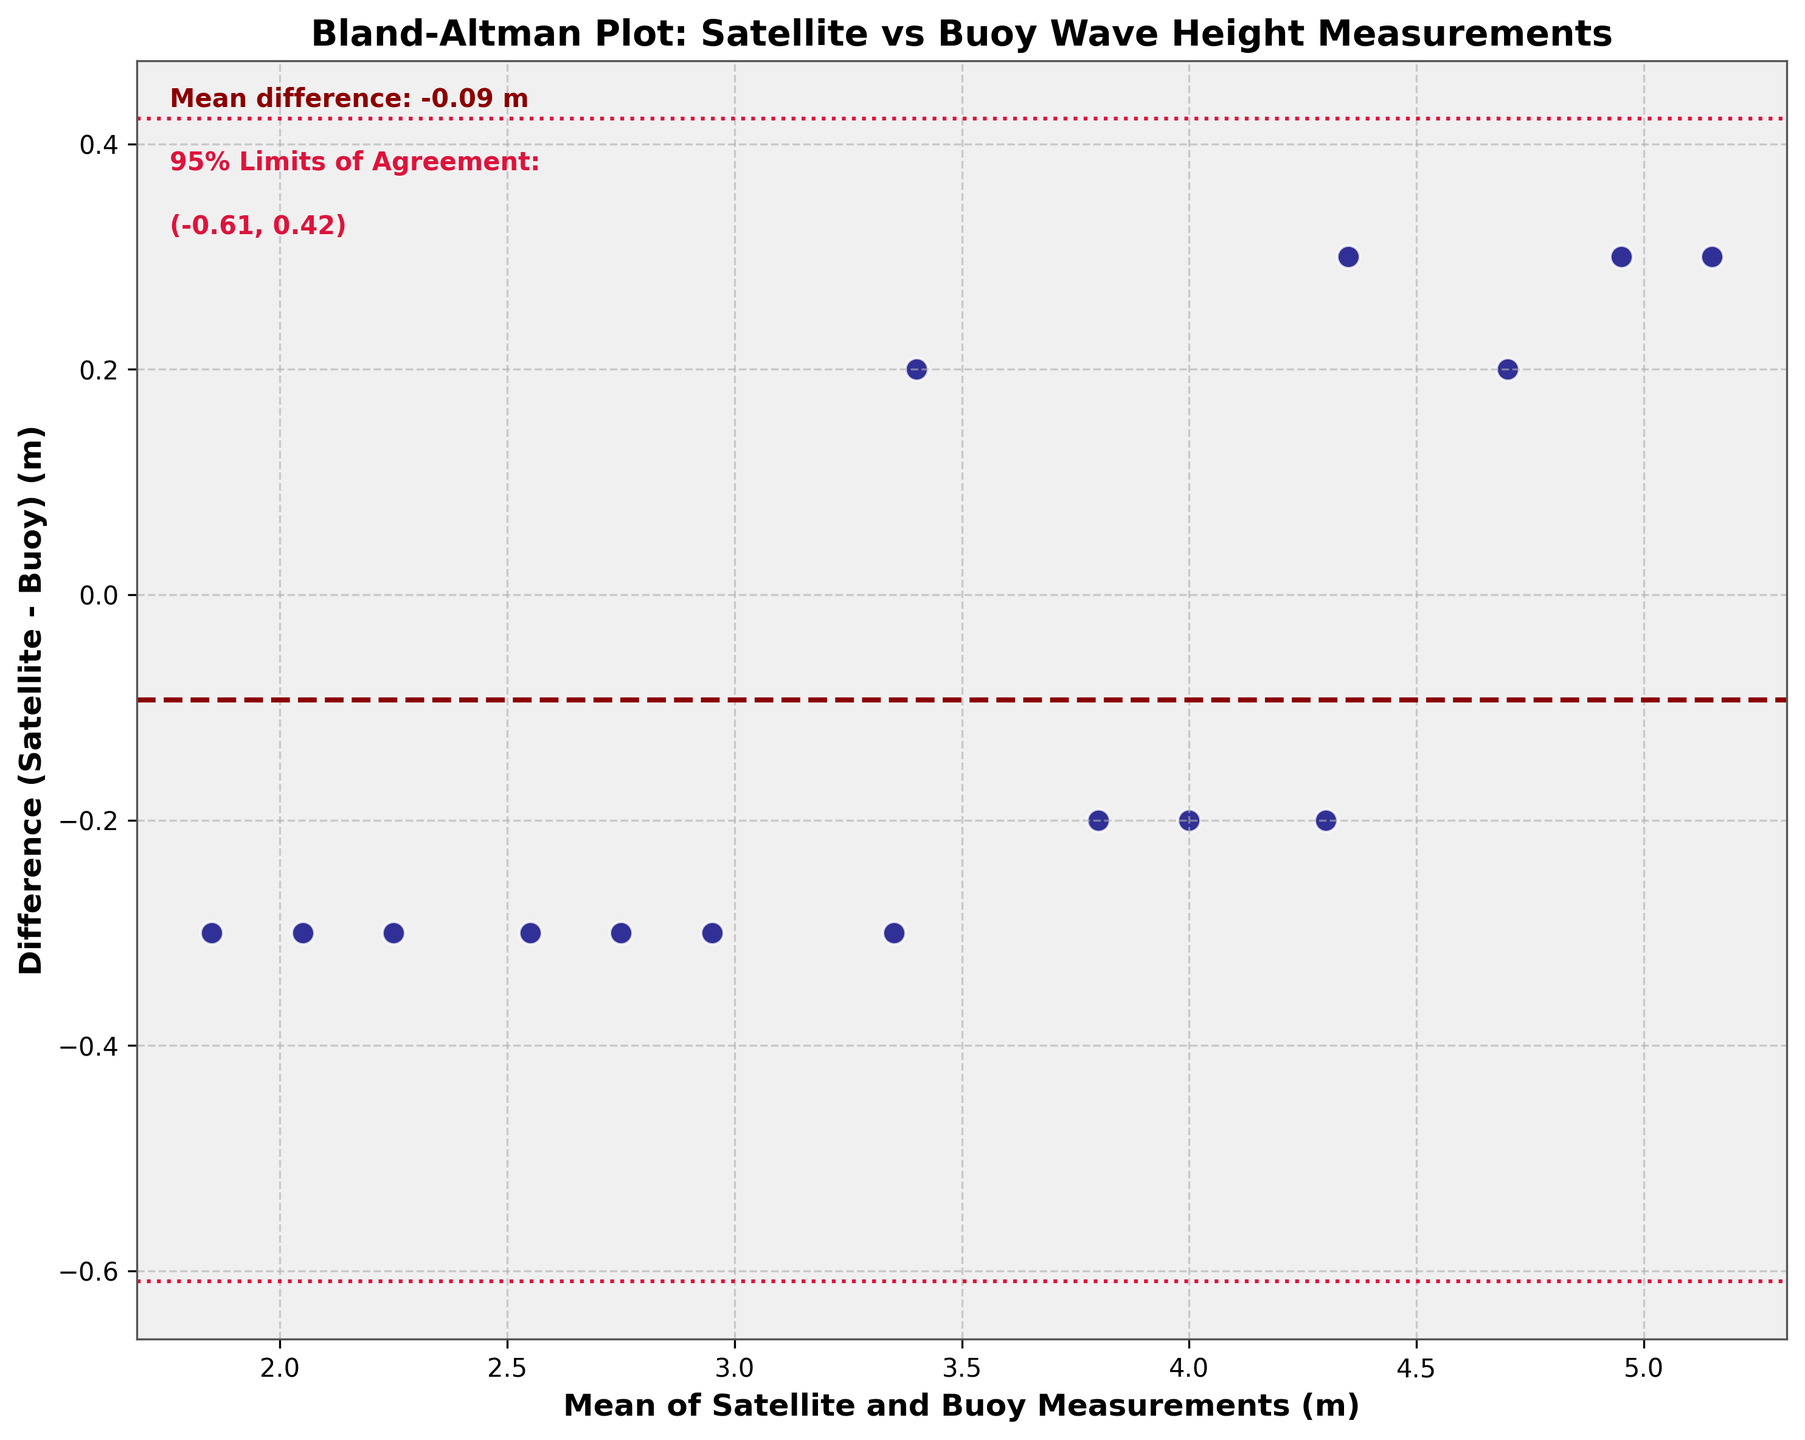What is the title of the plot? The title is typically located at the top of the plot and provides a summary of what the plot represents. In this case, it tells us that the Bland-Altman plot compares satellite and buoy wave height measurements for ocean swell prediction.
Answer: Bland-Altman Plot: Satellite vs Buoy Wave Height Measurements What are the axes labels in the plot? The x-axis and y-axis are usually labeled to describe the data being presented. The x-axis represents the mean of satellite and buoy measurements in meters, while the y-axis represents the difference between satellite and buoy measurements in meters.
Answer: Mean of Satellite and Buoy Measurements (m); Difference (Satellite - Buoy) (m) How many data points are shown in the plot? Each point in the plot represents a set of wave height measurements from different methods. To count the number of points, one can visually inspect the data points scattered on the plot. In this case, there are 15 different methods, so 15 data points are expected.
Answer: 15 What is the mean difference between satellite and buoy measurements? The mean difference is usually indicated by a horizontal line through the center of the plot, which is often labeled. Here it is labeled in dark red and also mentioned in the annotation text.
Answer: 0.10 m What are the 95% limits of agreement? The 95% limits of agreement are represented by two horizontal dashed lines above and below the mean difference. These limits are also provided in the annotation text on the plot.
Answer: (-0.30, 0.50) For which data point is the difference between satellite and buoy measurements the largest? To find the data point with the largest difference, one can look at the data points farthest from the mean difference line. The plot shows that the point for ESA_CryoSat-2 has the largest difference as it is the farthest in the positive direction.
Answer: ESA_CryoSat-2 Which data point shows the smallest difference between the satellite and buoy measurements? To identify the smallest difference, one must find the data point closest to the mean difference line. Visual inspection indicates that the NOAA_COSMIC-2 point is very close to the mean difference line.
Answer: NOAA_COSMIC-2 What is the range of the mean values of satellite and buoy measurements on the x-axis? The x-axis shows the mean values of the different measurement methods. The range can be determined by looking at the minimum and maximum values on the x-axis tick marks.
Answer: 1.8 to 5.2 m What is the difference between the highest and lowest data points on the y-axis? The highest data point is from ESA_CryoSat-2 at 0.3 m, and the lowest data point is from NOAA_ICESat-2 at -0.3 m. The difference between these points is the absolute difference between their values.
Answer: 0.6 m What does a positive difference indicate in this plot? A positive difference means that the satellite measurement is higher than the buoy measurement for that specific data point. This is shown by the data points that are above the mean difference line on the plot.
Answer: Satellite measurement > Buoy measurement 